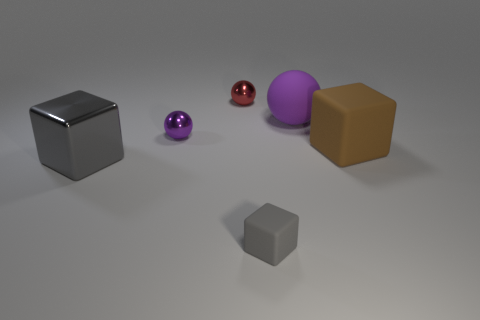What material is the block that is behind the big gray shiny block?
Offer a very short reply. Rubber. The gray matte cube is what size?
Give a very brief answer. Small. Are the thing that is in front of the large gray metal thing and the large purple thing made of the same material?
Your answer should be compact. Yes. How many large green things are there?
Offer a terse response. 0. How many objects are either purple matte spheres or big objects?
Make the answer very short. 3. What number of big gray metal objects are behind the rubber object to the left of the big purple ball behind the small matte thing?
Make the answer very short. 1. Are there any other things that are the same color as the metal block?
Keep it short and to the point. Yes. There is a cube that is left of the red ball; is it the same color as the big matte thing that is behind the purple metal sphere?
Keep it short and to the point. No. Are there more red things that are in front of the small matte block than balls that are in front of the brown thing?
Ensure brevity in your answer.  No. What material is the tiny gray thing?
Offer a very short reply. Rubber. 